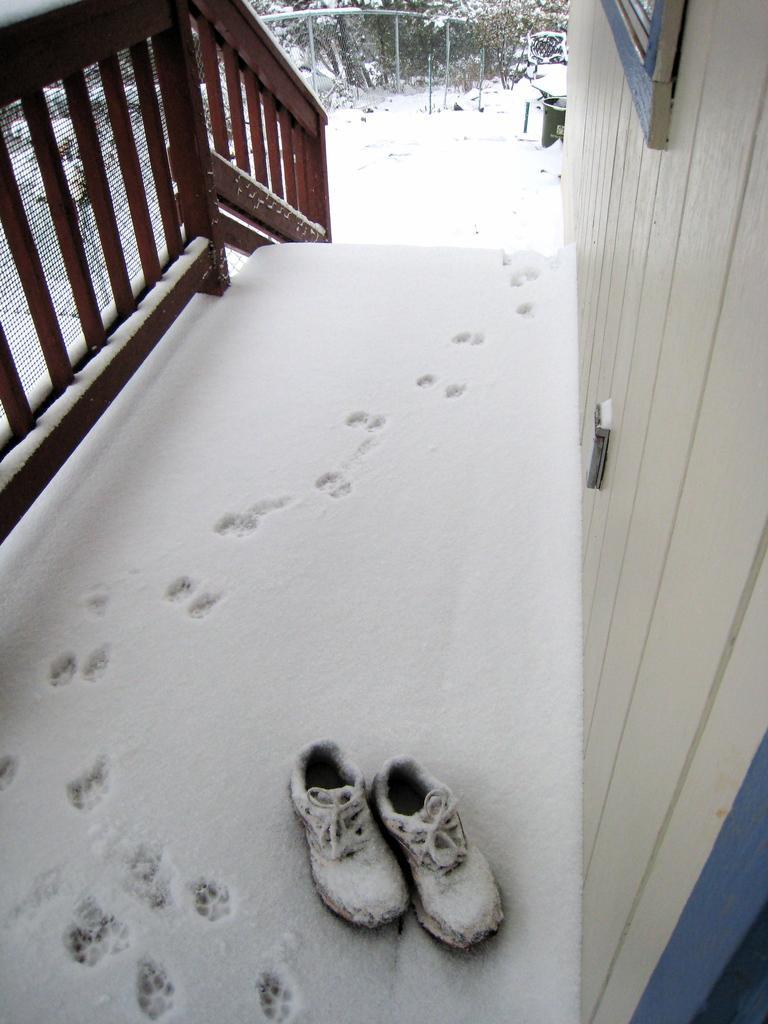Please provide a concise description of this image. In this image, we can see the snow and footwear. On the right side of the image, we can see the wall. Left side top corner, there is a railing. Top of the image, we can see few trees, poles, objects and snow. 